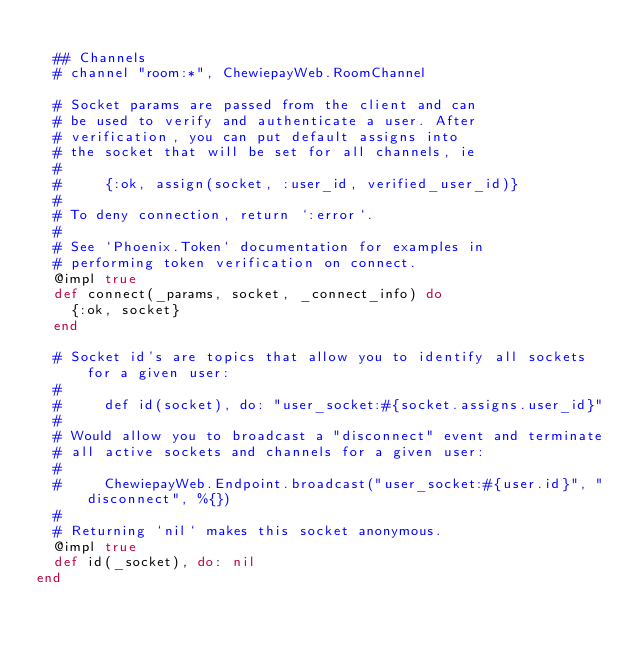Convert code to text. <code><loc_0><loc_0><loc_500><loc_500><_Elixir_>
  ## Channels
  # channel "room:*", ChewiepayWeb.RoomChannel

  # Socket params are passed from the client and can
  # be used to verify and authenticate a user. After
  # verification, you can put default assigns into
  # the socket that will be set for all channels, ie
  #
  #     {:ok, assign(socket, :user_id, verified_user_id)}
  #
  # To deny connection, return `:error`.
  #
  # See `Phoenix.Token` documentation for examples in
  # performing token verification on connect.
  @impl true
  def connect(_params, socket, _connect_info) do
    {:ok, socket}
  end

  # Socket id's are topics that allow you to identify all sockets for a given user:
  #
  #     def id(socket), do: "user_socket:#{socket.assigns.user_id}"
  #
  # Would allow you to broadcast a "disconnect" event and terminate
  # all active sockets and channels for a given user:
  #
  #     ChewiepayWeb.Endpoint.broadcast("user_socket:#{user.id}", "disconnect", %{})
  #
  # Returning `nil` makes this socket anonymous.
  @impl true
  def id(_socket), do: nil
end
</code> 